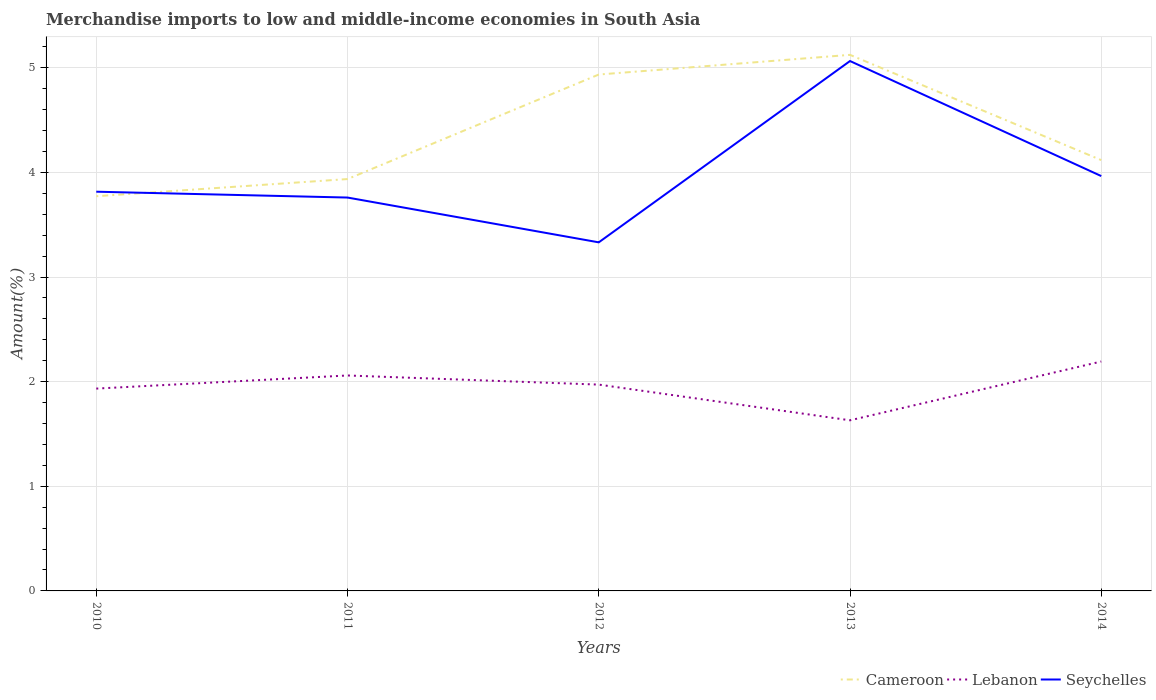How many different coloured lines are there?
Offer a terse response. 3. Across all years, what is the maximum percentage of amount earned from merchandise imports in Cameroon?
Offer a terse response. 3.77. In which year was the percentage of amount earned from merchandise imports in Seychelles maximum?
Offer a very short reply. 2012. What is the total percentage of amount earned from merchandise imports in Lebanon in the graph?
Your answer should be very brief. 0.43. What is the difference between the highest and the second highest percentage of amount earned from merchandise imports in Cameroon?
Give a very brief answer. 1.35. How many lines are there?
Your answer should be very brief. 3. How many years are there in the graph?
Keep it short and to the point. 5. Does the graph contain grids?
Keep it short and to the point. Yes. How are the legend labels stacked?
Your answer should be very brief. Horizontal. What is the title of the graph?
Your answer should be very brief. Merchandise imports to low and middle-income economies in South Asia. What is the label or title of the Y-axis?
Your answer should be very brief. Amount(%). What is the Amount(%) of Cameroon in 2010?
Provide a succinct answer. 3.77. What is the Amount(%) in Lebanon in 2010?
Make the answer very short. 1.93. What is the Amount(%) of Seychelles in 2010?
Ensure brevity in your answer.  3.82. What is the Amount(%) of Cameroon in 2011?
Provide a succinct answer. 3.94. What is the Amount(%) in Lebanon in 2011?
Provide a succinct answer. 2.06. What is the Amount(%) of Seychelles in 2011?
Give a very brief answer. 3.76. What is the Amount(%) in Cameroon in 2012?
Offer a terse response. 4.94. What is the Amount(%) of Lebanon in 2012?
Provide a succinct answer. 1.97. What is the Amount(%) of Seychelles in 2012?
Provide a succinct answer. 3.33. What is the Amount(%) in Cameroon in 2013?
Provide a succinct answer. 5.12. What is the Amount(%) of Lebanon in 2013?
Your response must be concise. 1.63. What is the Amount(%) in Seychelles in 2013?
Provide a succinct answer. 5.06. What is the Amount(%) of Cameroon in 2014?
Your response must be concise. 4.12. What is the Amount(%) in Lebanon in 2014?
Offer a terse response. 2.19. What is the Amount(%) in Seychelles in 2014?
Offer a very short reply. 3.97. Across all years, what is the maximum Amount(%) of Cameroon?
Provide a short and direct response. 5.12. Across all years, what is the maximum Amount(%) in Lebanon?
Make the answer very short. 2.19. Across all years, what is the maximum Amount(%) of Seychelles?
Keep it short and to the point. 5.06. Across all years, what is the minimum Amount(%) in Cameroon?
Keep it short and to the point. 3.77. Across all years, what is the minimum Amount(%) in Lebanon?
Offer a very short reply. 1.63. Across all years, what is the minimum Amount(%) of Seychelles?
Your answer should be compact. 3.33. What is the total Amount(%) of Cameroon in the graph?
Your response must be concise. 21.89. What is the total Amount(%) in Lebanon in the graph?
Provide a succinct answer. 9.79. What is the total Amount(%) in Seychelles in the graph?
Offer a terse response. 19.94. What is the difference between the Amount(%) in Cameroon in 2010 and that in 2011?
Give a very brief answer. -0.16. What is the difference between the Amount(%) of Lebanon in 2010 and that in 2011?
Offer a terse response. -0.13. What is the difference between the Amount(%) in Seychelles in 2010 and that in 2011?
Provide a succinct answer. 0.06. What is the difference between the Amount(%) in Cameroon in 2010 and that in 2012?
Provide a short and direct response. -1.16. What is the difference between the Amount(%) in Lebanon in 2010 and that in 2012?
Offer a very short reply. -0.04. What is the difference between the Amount(%) of Seychelles in 2010 and that in 2012?
Give a very brief answer. 0.48. What is the difference between the Amount(%) in Cameroon in 2010 and that in 2013?
Your response must be concise. -1.35. What is the difference between the Amount(%) in Lebanon in 2010 and that in 2013?
Your answer should be compact. 0.3. What is the difference between the Amount(%) in Seychelles in 2010 and that in 2013?
Provide a short and direct response. -1.25. What is the difference between the Amount(%) of Cameroon in 2010 and that in 2014?
Your answer should be compact. -0.35. What is the difference between the Amount(%) in Lebanon in 2010 and that in 2014?
Provide a succinct answer. -0.26. What is the difference between the Amount(%) in Seychelles in 2010 and that in 2014?
Offer a terse response. -0.15. What is the difference between the Amount(%) in Cameroon in 2011 and that in 2012?
Give a very brief answer. -1. What is the difference between the Amount(%) in Lebanon in 2011 and that in 2012?
Your response must be concise. 0.09. What is the difference between the Amount(%) in Seychelles in 2011 and that in 2012?
Your answer should be compact. 0.43. What is the difference between the Amount(%) of Cameroon in 2011 and that in 2013?
Your response must be concise. -1.19. What is the difference between the Amount(%) in Lebanon in 2011 and that in 2013?
Provide a succinct answer. 0.43. What is the difference between the Amount(%) in Seychelles in 2011 and that in 2013?
Your answer should be very brief. -1.3. What is the difference between the Amount(%) of Cameroon in 2011 and that in 2014?
Ensure brevity in your answer.  -0.18. What is the difference between the Amount(%) in Lebanon in 2011 and that in 2014?
Your answer should be compact. -0.13. What is the difference between the Amount(%) in Seychelles in 2011 and that in 2014?
Provide a succinct answer. -0.21. What is the difference between the Amount(%) of Cameroon in 2012 and that in 2013?
Your answer should be very brief. -0.19. What is the difference between the Amount(%) of Lebanon in 2012 and that in 2013?
Offer a terse response. 0.34. What is the difference between the Amount(%) of Seychelles in 2012 and that in 2013?
Provide a succinct answer. -1.73. What is the difference between the Amount(%) in Cameroon in 2012 and that in 2014?
Your answer should be compact. 0.82. What is the difference between the Amount(%) in Lebanon in 2012 and that in 2014?
Provide a succinct answer. -0.22. What is the difference between the Amount(%) of Seychelles in 2012 and that in 2014?
Offer a terse response. -0.63. What is the difference between the Amount(%) of Lebanon in 2013 and that in 2014?
Offer a very short reply. -0.56. What is the difference between the Amount(%) in Seychelles in 2013 and that in 2014?
Offer a terse response. 1.1. What is the difference between the Amount(%) of Cameroon in 2010 and the Amount(%) of Lebanon in 2011?
Give a very brief answer. 1.71. What is the difference between the Amount(%) of Cameroon in 2010 and the Amount(%) of Seychelles in 2011?
Offer a terse response. 0.01. What is the difference between the Amount(%) in Lebanon in 2010 and the Amount(%) in Seychelles in 2011?
Keep it short and to the point. -1.83. What is the difference between the Amount(%) of Cameroon in 2010 and the Amount(%) of Lebanon in 2012?
Keep it short and to the point. 1.8. What is the difference between the Amount(%) of Cameroon in 2010 and the Amount(%) of Seychelles in 2012?
Give a very brief answer. 0.44. What is the difference between the Amount(%) of Lebanon in 2010 and the Amount(%) of Seychelles in 2012?
Ensure brevity in your answer.  -1.4. What is the difference between the Amount(%) of Cameroon in 2010 and the Amount(%) of Lebanon in 2013?
Offer a very short reply. 2.14. What is the difference between the Amount(%) in Cameroon in 2010 and the Amount(%) in Seychelles in 2013?
Make the answer very short. -1.29. What is the difference between the Amount(%) of Lebanon in 2010 and the Amount(%) of Seychelles in 2013?
Your answer should be compact. -3.13. What is the difference between the Amount(%) of Cameroon in 2010 and the Amount(%) of Lebanon in 2014?
Offer a terse response. 1.58. What is the difference between the Amount(%) of Cameroon in 2010 and the Amount(%) of Seychelles in 2014?
Provide a succinct answer. -0.19. What is the difference between the Amount(%) in Lebanon in 2010 and the Amount(%) in Seychelles in 2014?
Provide a succinct answer. -2.03. What is the difference between the Amount(%) of Cameroon in 2011 and the Amount(%) of Lebanon in 2012?
Offer a terse response. 1.96. What is the difference between the Amount(%) in Cameroon in 2011 and the Amount(%) in Seychelles in 2012?
Give a very brief answer. 0.6. What is the difference between the Amount(%) in Lebanon in 2011 and the Amount(%) in Seychelles in 2012?
Provide a short and direct response. -1.27. What is the difference between the Amount(%) in Cameroon in 2011 and the Amount(%) in Lebanon in 2013?
Keep it short and to the point. 2.31. What is the difference between the Amount(%) of Cameroon in 2011 and the Amount(%) of Seychelles in 2013?
Give a very brief answer. -1.13. What is the difference between the Amount(%) of Lebanon in 2011 and the Amount(%) of Seychelles in 2013?
Provide a succinct answer. -3.01. What is the difference between the Amount(%) in Cameroon in 2011 and the Amount(%) in Lebanon in 2014?
Provide a short and direct response. 1.74. What is the difference between the Amount(%) of Cameroon in 2011 and the Amount(%) of Seychelles in 2014?
Your answer should be compact. -0.03. What is the difference between the Amount(%) in Lebanon in 2011 and the Amount(%) in Seychelles in 2014?
Your answer should be compact. -1.91. What is the difference between the Amount(%) in Cameroon in 2012 and the Amount(%) in Lebanon in 2013?
Provide a short and direct response. 3.31. What is the difference between the Amount(%) in Cameroon in 2012 and the Amount(%) in Seychelles in 2013?
Offer a terse response. -0.13. What is the difference between the Amount(%) of Lebanon in 2012 and the Amount(%) of Seychelles in 2013?
Your response must be concise. -3.09. What is the difference between the Amount(%) of Cameroon in 2012 and the Amount(%) of Lebanon in 2014?
Make the answer very short. 2.74. What is the difference between the Amount(%) of Cameroon in 2012 and the Amount(%) of Seychelles in 2014?
Offer a very short reply. 0.97. What is the difference between the Amount(%) of Lebanon in 2012 and the Amount(%) of Seychelles in 2014?
Give a very brief answer. -1.99. What is the difference between the Amount(%) in Cameroon in 2013 and the Amount(%) in Lebanon in 2014?
Make the answer very short. 2.93. What is the difference between the Amount(%) in Cameroon in 2013 and the Amount(%) in Seychelles in 2014?
Your answer should be very brief. 1.16. What is the difference between the Amount(%) in Lebanon in 2013 and the Amount(%) in Seychelles in 2014?
Offer a terse response. -2.33. What is the average Amount(%) of Cameroon per year?
Your answer should be very brief. 4.38. What is the average Amount(%) of Lebanon per year?
Your answer should be compact. 1.96. What is the average Amount(%) in Seychelles per year?
Make the answer very short. 3.99. In the year 2010, what is the difference between the Amount(%) of Cameroon and Amount(%) of Lebanon?
Provide a succinct answer. 1.84. In the year 2010, what is the difference between the Amount(%) in Cameroon and Amount(%) in Seychelles?
Give a very brief answer. -0.04. In the year 2010, what is the difference between the Amount(%) in Lebanon and Amount(%) in Seychelles?
Provide a short and direct response. -1.88. In the year 2011, what is the difference between the Amount(%) of Cameroon and Amount(%) of Lebanon?
Ensure brevity in your answer.  1.88. In the year 2011, what is the difference between the Amount(%) in Cameroon and Amount(%) in Seychelles?
Give a very brief answer. 0.18. In the year 2011, what is the difference between the Amount(%) in Lebanon and Amount(%) in Seychelles?
Provide a succinct answer. -1.7. In the year 2012, what is the difference between the Amount(%) in Cameroon and Amount(%) in Lebanon?
Provide a short and direct response. 2.96. In the year 2012, what is the difference between the Amount(%) in Cameroon and Amount(%) in Seychelles?
Your response must be concise. 1.6. In the year 2012, what is the difference between the Amount(%) in Lebanon and Amount(%) in Seychelles?
Your answer should be very brief. -1.36. In the year 2013, what is the difference between the Amount(%) of Cameroon and Amount(%) of Lebanon?
Your answer should be compact. 3.49. In the year 2013, what is the difference between the Amount(%) of Cameroon and Amount(%) of Seychelles?
Provide a succinct answer. 0.06. In the year 2013, what is the difference between the Amount(%) in Lebanon and Amount(%) in Seychelles?
Ensure brevity in your answer.  -3.43. In the year 2014, what is the difference between the Amount(%) of Cameroon and Amount(%) of Lebanon?
Your answer should be compact. 1.93. In the year 2014, what is the difference between the Amount(%) in Cameroon and Amount(%) in Seychelles?
Offer a very short reply. 0.15. In the year 2014, what is the difference between the Amount(%) of Lebanon and Amount(%) of Seychelles?
Give a very brief answer. -1.77. What is the ratio of the Amount(%) of Cameroon in 2010 to that in 2011?
Your response must be concise. 0.96. What is the ratio of the Amount(%) of Lebanon in 2010 to that in 2011?
Your answer should be very brief. 0.94. What is the ratio of the Amount(%) of Seychelles in 2010 to that in 2011?
Your answer should be compact. 1.01. What is the ratio of the Amount(%) of Cameroon in 2010 to that in 2012?
Offer a very short reply. 0.76. What is the ratio of the Amount(%) of Lebanon in 2010 to that in 2012?
Ensure brevity in your answer.  0.98. What is the ratio of the Amount(%) of Seychelles in 2010 to that in 2012?
Provide a succinct answer. 1.15. What is the ratio of the Amount(%) in Cameroon in 2010 to that in 2013?
Your answer should be compact. 0.74. What is the ratio of the Amount(%) in Lebanon in 2010 to that in 2013?
Your answer should be very brief. 1.19. What is the ratio of the Amount(%) of Seychelles in 2010 to that in 2013?
Offer a terse response. 0.75. What is the ratio of the Amount(%) of Cameroon in 2010 to that in 2014?
Provide a succinct answer. 0.92. What is the ratio of the Amount(%) of Lebanon in 2010 to that in 2014?
Offer a very short reply. 0.88. What is the ratio of the Amount(%) in Seychelles in 2010 to that in 2014?
Ensure brevity in your answer.  0.96. What is the ratio of the Amount(%) in Cameroon in 2011 to that in 2012?
Provide a succinct answer. 0.8. What is the ratio of the Amount(%) of Lebanon in 2011 to that in 2012?
Offer a very short reply. 1.04. What is the ratio of the Amount(%) of Seychelles in 2011 to that in 2012?
Provide a short and direct response. 1.13. What is the ratio of the Amount(%) in Cameroon in 2011 to that in 2013?
Ensure brevity in your answer.  0.77. What is the ratio of the Amount(%) in Lebanon in 2011 to that in 2013?
Give a very brief answer. 1.26. What is the ratio of the Amount(%) of Seychelles in 2011 to that in 2013?
Ensure brevity in your answer.  0.74. What is the ratio of the Amount(%) in Cameroon in 2011 to that in 2014?
Ensure brevity in your answer.  0.96. What is the ratio of the Amount(%) in Lebanon in 2011 to that in 2014?
Provide a succinct answer. 0.94. What is the ratio of the Amount(%) in Seychelles in 2011 to that in 2014?
Make the answer very short. 0.95. What is the ratio of the Amount(%) of Cameroon in 2012 to that in 2013?
Offer a terse response. 0.96. What is the ratio of the Amount(%) in Lebanon in 2012 to that in 2013?
Offer a terse response. 1.21. What is the ratio of the Amount(%) of Seychelles in 2012 to that in 2013?
Make the answer very short. 0.66. What is the ratio of the Amount(%) of Cameroon in 2012 to that in 2014?
Give a very brief answer. 1.2. What is the ratio of the Amount(%) of Lebanon in 2012 to that in 2014?
Give a very brief answer. 0.9. What is the ratio of the Amount(%) of Seychelles in 2012 to that in 2014?
Your answer should be compact. 0.84. What is the ratio of the Amount(%) in Cameroon in 2013 to that in 2014?
Your answer should be compact. 1.24. What is the ratio of the Amount(%) of Lebanon in 2013 to that in 2014?
Keep it short and to the point. 0.74. What is the ratio of the Amount(%) in Seychelles in 2013 to that in 2014?
Provide a succinct answer. 1.28. What is the difference between the highest and the second highest Amount(%) of Cameroon?
Keep it short and to the point. 0.19. What is the difference between the highest and the second highest Amount(%) in Lebanon?
Keep it short and to the point. 0.13. What is the difference between the highest and the second highest Amount(%) in Seychelles?
Provide a succinct answer. 1.1. What is the difference between the highest and the lowest Amount(%) in Cameroon?
Provide a short and direct response. 1.35. What is the difference between the highest and the lowest Amount(%) in Lebanon?
Make the answer very short. 0.56. What is the difference between the highest and the lowest Amount(%) of Seychelles?
Your answer should be very brief. 1.73. 